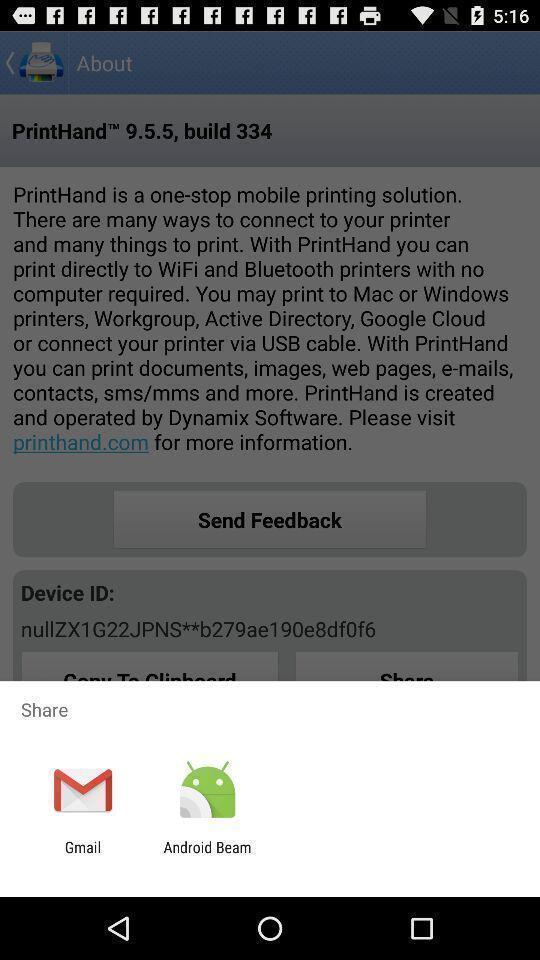Please provide a description for this image. Popup of applications to share the information. 